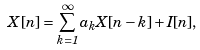<formula> <loc_0><loc_0><loc_500><loc_500>X [ n ] = \sum _ { k = 1 } ^ { \infty } a _ { k } X [ n - k ] + I [ n ] ,</formula> 